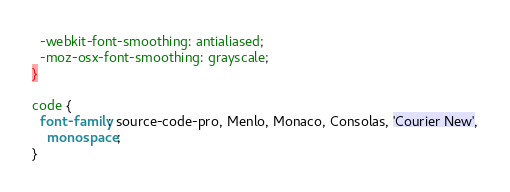<code> <loc_0><loc_0><loc_500><loc_500><_CSS_>  -webkit-font-smoothing: antialiased;
  -moz-osx-font-smoothing: grayscale;
}

code {
  font-family: source-code-pro, Menlo, Monaco, Consolas, 'Courier New',
    monospace;
}
</code> 